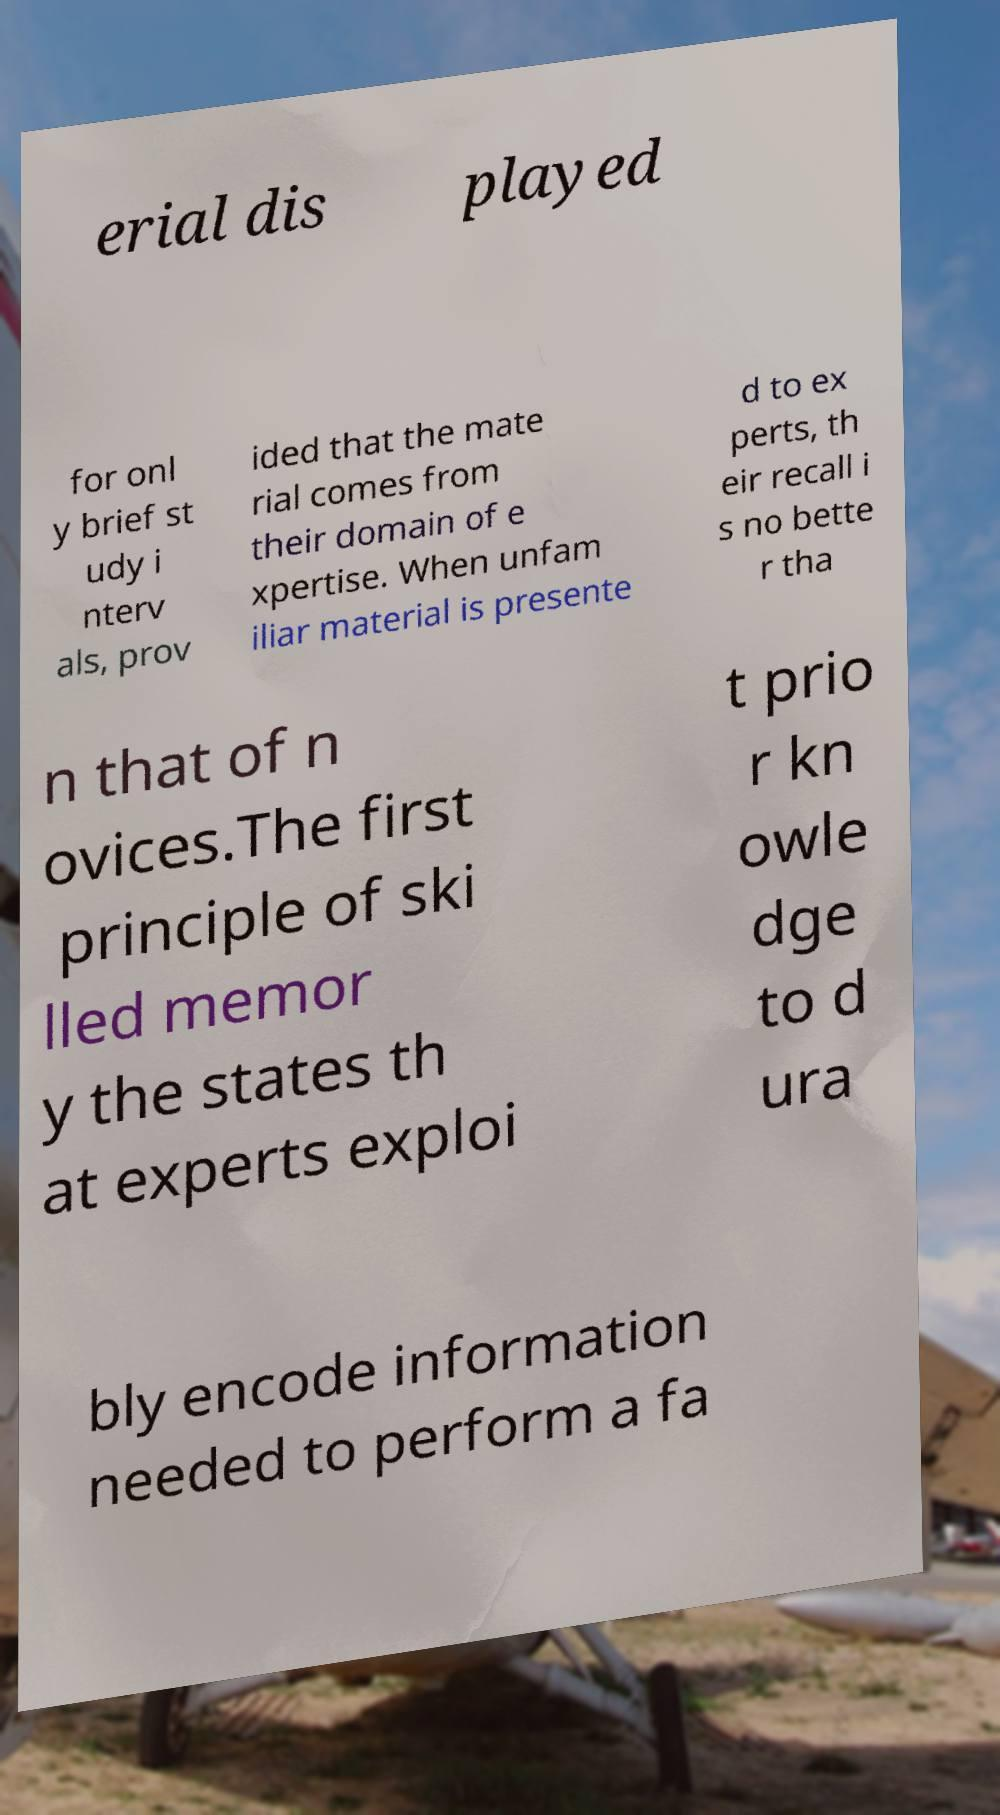There's text embedded in this image that I need extracted. Can you transcribe it verbatim? erial dis played for onl y brief st udy i nterv als, prov ided that the mate rial comes from their domain of e xpertise. When unfam iliar material is presente d to ex perts, th eir recall i s no bette r tha n that of n ovices.The first principle of ski lled memor y the states th at experts exploi t prio r kn owle dge to d ura bly encode information needed to perform a fa 